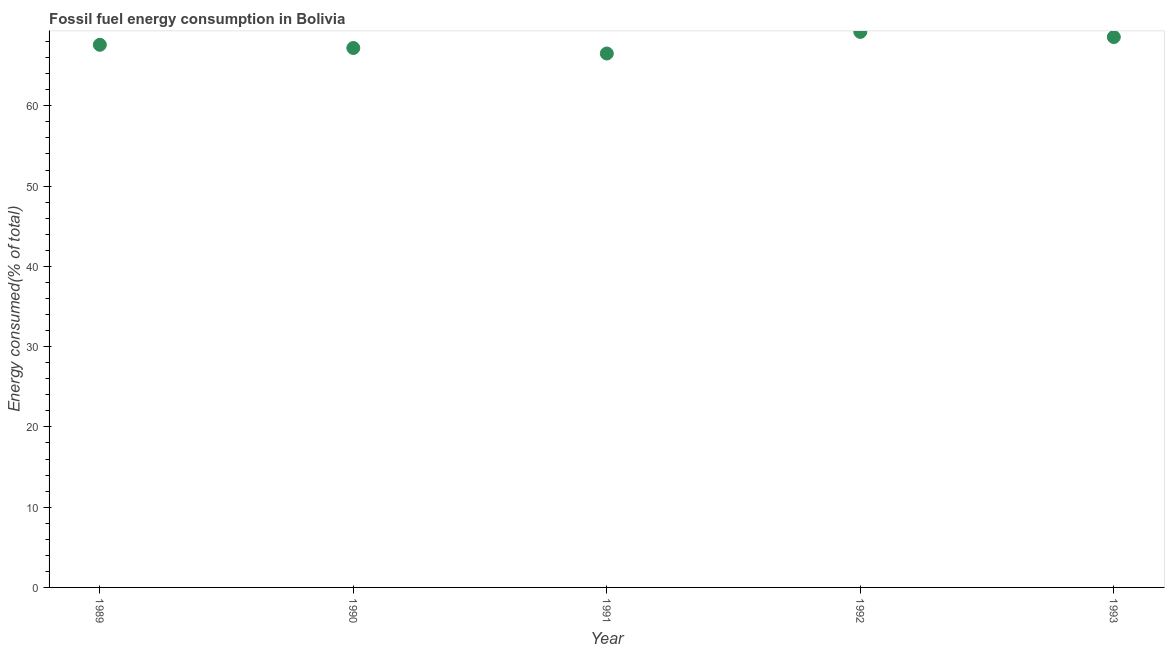What is the fossil fuel energy consumption in 1993?
Make the answer very short. 68.57. Across all years, what is the maximum fossil fuel energy consumption?
Offer a very short reply. 69.21. Across all years, what is the minimum fossil fuel energy consumption?
Provide a short and direct response. 66.52. In which year was the fossil fuel energy consumption minimum?
Offer a terse response. 1991. What is the sum of the fossil fuel energy consumption?
Offer a terse response. 339.11. What is the difference between the fossil fuel energy consumption in 1990 and 1993?
Your response must be concise. -1.37. What is the average fossil fuel energy consumption per year?
Offer a very short reply. 67.82. What is the median fossil fuel energy consumption?
Keep it short and to the point. 67.6. In how many years, is the fossil fuel energy consumption greater than 44 %?
Provide a short and direct response. 5. What is the ratio of the fossil fuel energy consumption in 1990 to that in 1993?
Keep it short and to the point. 0.98. Is the difference between the fossil fuel energy consumption in 1990 and 1991 greater than the difference between any two years?
Your answer should be very brief. No. What is the difference between the highest and the second highest fossil fuel energy consumption?
Ensure brevity in your answer.  0.64. What is the difference between the highest and the lowest fossil fuel energy consumption?
Offer a terse response. 2.69. Are the values on the major ticks of Y-axis written in scientific E-notation?
Offer a terse response. No. Does the graph contain any zero values?
Offer a very short reply. No. What is the title of the graph?
Make the answer very short. Fossil fuel energy consumption in Bolivia. What is the label or title of the Y-axis?
Ensure brevity in your answer.  Energy consumed(% of total). What is the Energy consumed(% of total) in 1989?
Your answer should be compact. 67.6. What is the Energy consumed(% of total) in 1990?
Provide a succinct answer. 67.2. What is the Energy consumed(% of total) in 1991?
Offer a very short reply. 66.52. What is the Energy consumed(% of total) in 1992?
Make the answer very short. 69.21. What is the Energy consumed(% of total) in 1993?
Give a very brief answer. 68.57. What is the difference between the Energy consumed(% of total) in 1989 and 1990?
Provide a short and direct response. 0.4. What is the difference between the Energy consumed(% of total) in 1989 and 1991?
Your answer should be very brief. 1.09. What is the difference between the Energy consumed(% of total) in 1989 and 1992?
Give a very brief answer. -1.61. What is the difference between the Energy consumed(% of total) in 1989 and 1993?
Offer a very short reply. -0.97. What is the difference between the Energy consumed(% of total) in 1990 and 1991?
Ensure brevity in your answer.  0.69. What is the difference between the Energy consumed(% of total) in 1990 and 1992?
Make the answer very short. -2.01. What is the difference between the Energy consumed(% of total) in 1990 and 1993?
Offer a very short reply. -1.37. What is the difference between the Energy consumed(% of total) in 1991 and 1992?
Make the answer very short. -2.69. What is the difference between the Energy consumed(% of total) in 1991 and 1993?
Provide a short and direct response. -2.05. What is the difference between the Energy consumed(% of total) in 1992 and 1993?
Make the answer very short. 0.64. What is the ratio of the Energy consumed(% of total) in 1989 to that in 1990?
Your answer should be very brief. 1.01. What is the ratio of the Energy consumed(% of total) in 1989 to that in 1991?
Provide a succinct answer. 1.02. What is the ratio of the Energy consumed(% of total) in 1989 to that in 1992?
Keep it short and to the point. 0.98. What is the ratio of the Energy consumed(% of total) in 1990 to that in 1991?
Provide a succinct answer. 1.01. What is the ratio of the Energy consumed(% of total) in 1991 to that in 1992?
Make the answer very short. 0.96. What is the ratio of the Energy consumed(% of total) in 1991 to that in 1993?
Your response must be concise. 0.97. 